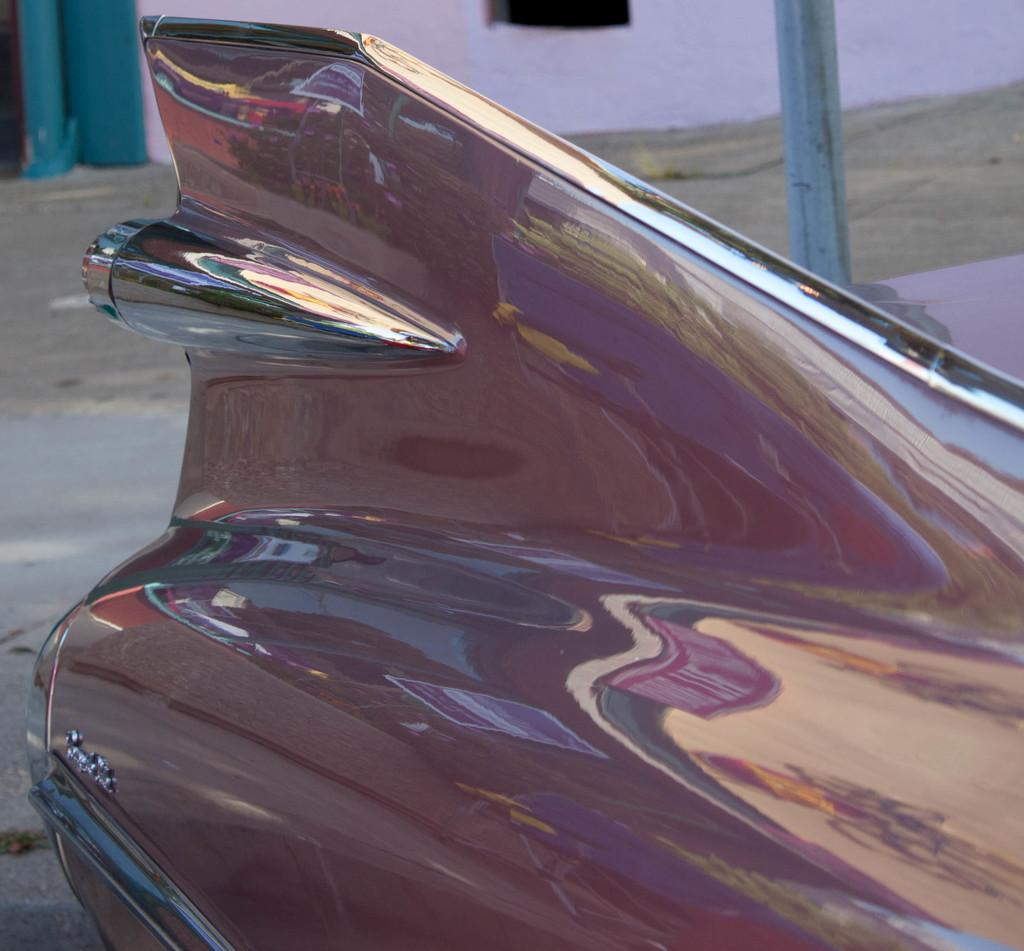What is the main subject in the front of the image? There is a car in the front of the image. What can be seen in the background of the image? There is a pole and a wall in the background of the image. What type of button can be seen on the car in the image? There is no button visible on the car in the image. 